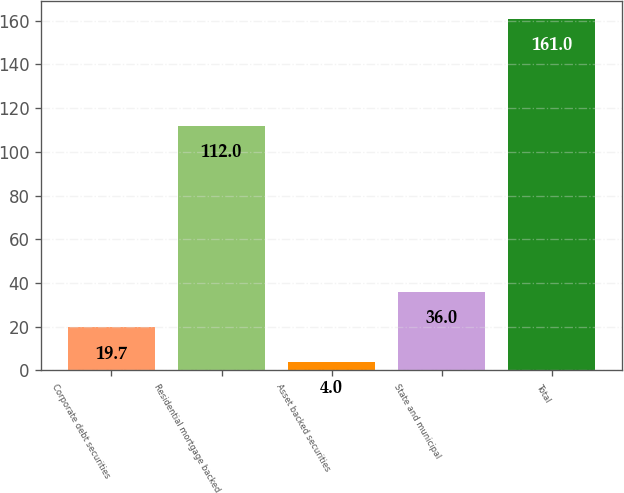<chart> <loc_0><loc_0><loc_500><loc_500><bar_chart><fcel>Corporate debt securities<fcel>Residential mortgage backed<fcel>Asset backed securities<fcel>State and municipal<fcel>Total<nl><fcel>19.7<fcel>112<fcel>4<fcel>36<fcel>161<nl></chart> 